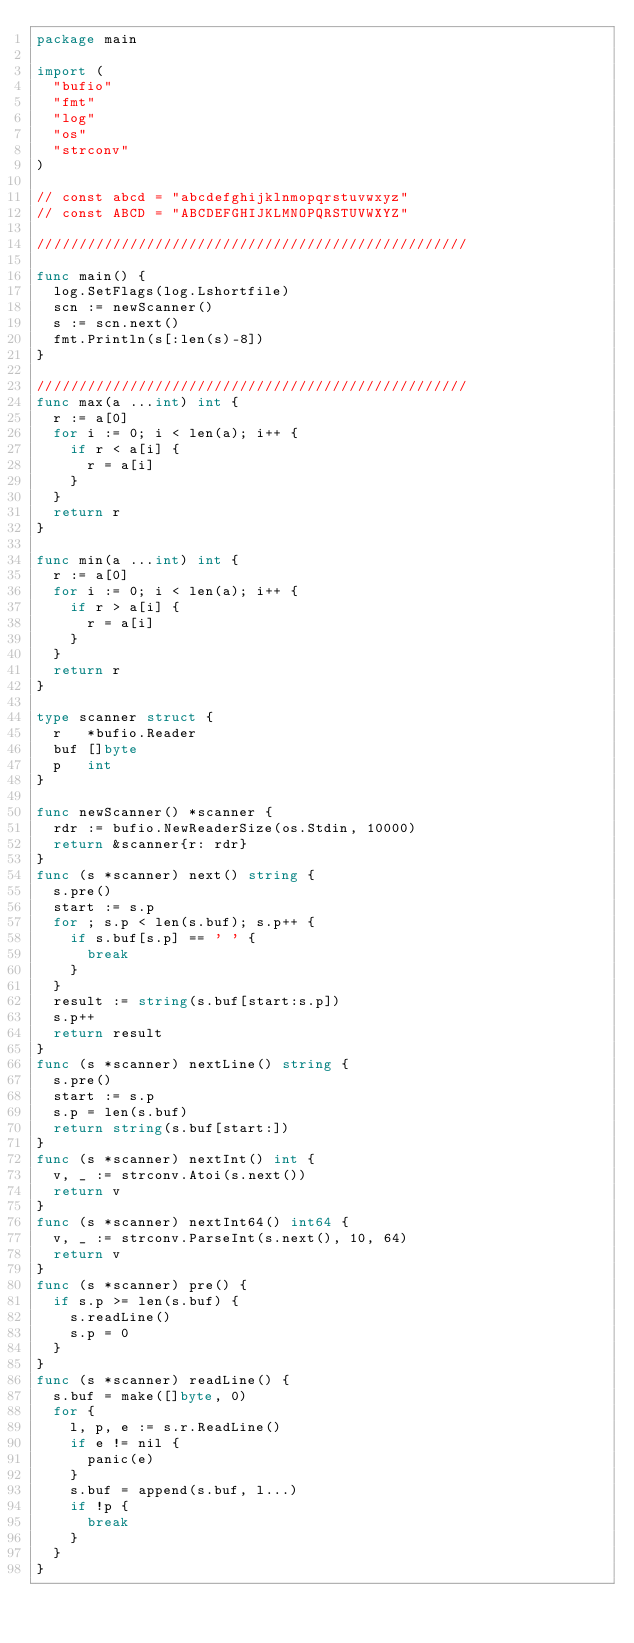Convert code to text. <code><loc_0><loc_0><loc_500><loc_500><_Go_>package main

import (
	"bufio"
	"fmt"
	"log"
	"os"
	"strconv"
)

// const abcd = "abcdefghijklnmopqrstuvwxyz"
// const ABCD = "ABCDEFGHIJKLMNOPQRSTUVWXYZ"

///////////////////////////////////////////////////

func main() {
	log.SetFlags(log.Lshortfile)
	scn := newScanner()
	s := scn.next()
	fmt.Println(s[:len(s)-8])
}

///////////////////////////////////////////////////
func max(a ...int) int {
	r := a[0]
	for i := 0; i < len(a); i++ {
		if r < a[i] {
			r = a[i]
		}
	}
	return r
}

func min(a ...int) int {
	r := a[0]
	for i := 0; i < len(a); i++ {
		if r > a[i] {
			r = a[i]
		}
	}
	return r
}

type scanner struct {
	r   *bufio.Reader
	buf []byte
	p   int
}

func newScanner() *scanner {
	rdr := bufio.NewReaderSize(os.Stdin, 10000)
	return &scanner{r: rdr}
}
func (s *scanner) next() string {
	s.pre()
	start := s.p
	for ; s.p < len(s.buf); s.p++ {
		if s.buf[s.p] == ' ' {
			break
		}
	}
	result := string(s.buf[start:s.p])
	s.p++
	return result
}
func (s *scanner) nextLine() string {
	s.pre()
	start := s.p
	s.p = len(s.buf)
	return string(s.buf[start:])
}
func (s *scanner) nextInt() int {
	v, _ := strconv.Atoi(s.next())
	return v
}
func (s *scanner) nextInt64() int64 {
	v, _ := strconv.ParseInt(s.next(), 10, 64)
	return v
}
func (s *scanner) pre() {
	if s.p >= len(s.buf) {
		s.readLine()
		s.p = 0
	}
}
func (s *scanner) readLine() {
	s.buf = make([]byte, 0)
	for {
		l, p, e := s.r.ReadLine()
		if e != nil {
			panic(e)
		}
		s.buf = append(s.buf, l...)
		if !p {
			break
		}
	}
}
</code> 